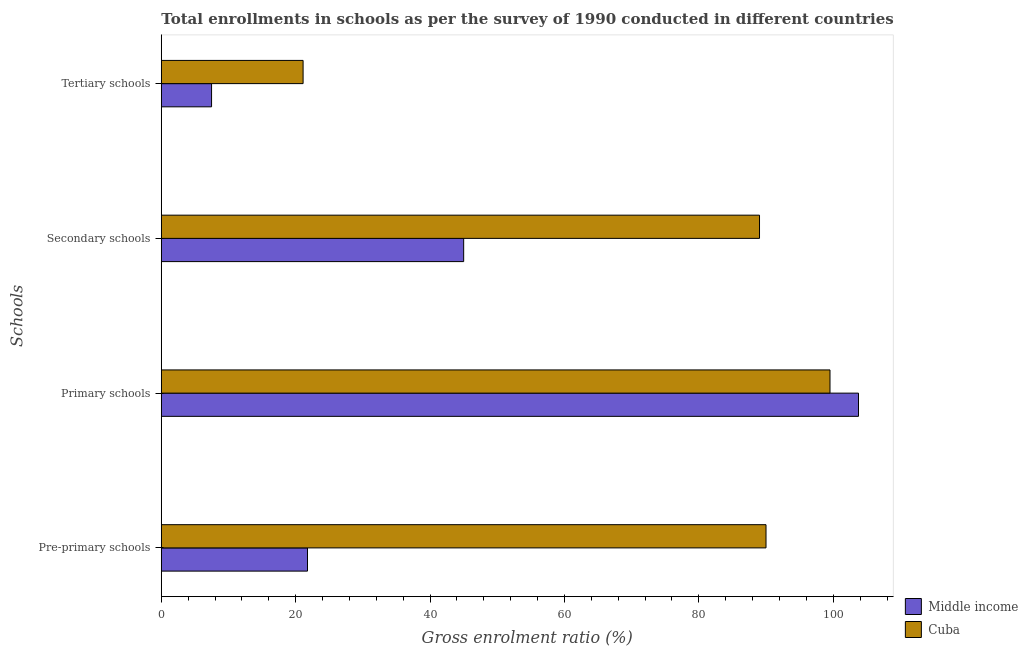How many different coloured bars are there?
Provide a succinct answer. 2. How many groups of bars are there?
Ensure brevity in your answer.  4. Are the number of bars per tick equal to the number of legend labels?
Your answer should be compact. Yes. What is the label of the 4th group of bars from the top?
Provide a short and direct response. Pre-primary schools. What is the gross enrolment ratio in pre-primary schools in Middle income?
Offer a very short reply. 21.76. Across all countries, what is the maximum gross enrolment ratio in primary schools?
Your answer should be compact. 103.76. Across all countries, what is the minimum gross enrolment ratio in primary schools?
Ensure brevity in your answer.  99.52. In which country was the gross enrolment ratio in tertiary schools maximum?
Your answer should be very brief. Cuba. What is the total gross enrolment ratio in tertiary schools in the graph?
Your answer should be compact. 28.58. What is the difference between the gross enrolment ratio in primary schools in Middle income and that in Cuba?
Offer a very short reply. 4.24. What is the difference between the gross enrolment ratio in primary schools in Middle income and the gross enrolment ratio in secondary schools in Cuba?
Ensure brevity in your answer.  14.73. What is the average gross enrolment ratio in pre-primary schools per country?
Offer a terse response. 55.88. What is the difference between the gross enrolment ratio in primary schools and gross enrolment ratio in secondary schools in Middle income?
Offer a very short reply. 58.76. What is the ratio of the gross enrolment ratio in primary schools in Cuba to that in Middle income?
Keep it short and to the point. 0.96. What is the difference between the highest and the second highest gross enrolment ratio in secondary schools?
Your answer should be compact. 44.03. What is the difference between the highest and the lowest gross enrolment ratio in tertiary schools?
Keep it short and to the point. 13.62. In how many countries, is the gross enrolment ratio in tertiary schools greater than the average gross enrolment ratio in tertiary schools taken over all countries?
Offer a terse response. 1. Is the sum of the gross enrolment ratio in primary schools in Middle income and Cuba greater than the maximum gross enrolment ratio in tertiary schools across all countries?
Keep it short and to the point. Yes. Is it the case that in every country, the sum of the gross enrolment ratio in tertiary schools and gross enrolment ratio in secondary schools is greater than the sum of gross enrolment ratio in pre-primary schools and gross enrolment ratio in primary schools?
Make the answer very short. No. What does the 1st bar from the top in Primary schools represents?
Offer a very short reply. Cuba. What does the 2nd bar from the bottom in Pre-primary schools represents?
Your response must be concise. Cuba. How many countries are there in the graph?
Your answer should be compact. 2. What is the difference between two consecutive major ticks on the X-axis?
Provide a succinct answer. 20. Are the values on the major ticks of X-axis written in scientific E-notation?
Keep it short and to the point. No. Does the graph contain any zero values?
Give a very brief answer. No. Where does the legend appear in the graph?
Make the answer very short. Bottom right. What is the title of the graph?
Provide a short and direct response. Total enrollments in schools as per the survey of 1990 conducted in different countries. What is the label or title of the X-axis?
Offer a terse response. Gross enrolment ratio (%). What is the label or title of the Y-axis?
Your answer should be compact. Schools. What is the Gross enrolment ratio (%) in Middle income in Pre-primary schools?
Give a very brief answer. 21.76. What is the Gross enrolment ratio (%) in Cuba in Pre-primary schools?
Offer a terse response. 89.99. What is the Gross enrolment ratio (%) of Middle income in Primary schools?
Provide a short and direct response. 103.76. What is the Gross enrolment ratio (%) in Cuba in Primary schools?
Offer a terse response. 99.52. What is the Gross enrolment ratio (%) of Middle income in Secondary schools?
Offer a terse response. 45. What is the Gross enrolment ratio (%) of Cuba in Secondary schools?
Offer a terse response. 89.03. What is the Gross enrolment ratio (%) in Middle income in Tertiary schools?
Ensure brevity in your answer.  7.48. What is the Gross enrolment ratio (%) of Cuba in Tertiary schools?
Make the answer very short. 21.1. Across all Schools, what is the maximum Gross enrolment ratio (%) in Middle income?
Keep it short and to the point. 103.76. Across all Schools, what is the maximum Gross enrolment ratio (%) in Cuba?
Provide a short and direct response. 99.52. Across all Schools, what is the minimum Gross enrolment ratio (%) in Middle income?
Offer a terse response. 7.48. Across all Schools, what is the minimum Gross enrolment ratio (%) in Cuba?
Your answer should be very brief. 21.1. What is the total Gross enrolment ratio (%) of Middle income in the graph?
Offer a very short reply. 177.99. What is the total Gross enrolment ratio (%) of Cuba in the graph?
Ensure brevity in your answer.  299.64. What is the difference between the Gross enrolment ratio (%) in Middle income in Pre-primary schools and that in Primary schools?
Make the answer very short. -82. What is the difference between the Gross enrolment ratio (%) in Cuba in Pre-primary schools and that in Primary schools?
Your answer should be very brief. -9.52. What is the difference between the Gross enrolment ratio (%) of Middle income in Pre-primary schools and that in Secondary schools?
Give a very brief answer. -23.24. What is the difference between the Gross enrolment ratio (%) of Cuba in Pre-primary schools and that in Secondary schools?
Your answer should be very brief. 0.97. What is the difference between the Gross enrolment ratio (%) in Middle income in Pre-primary schools and that in Tertiary schools?
Your answer should be very brief. 14.28. What is the difference between the Gross enrolment ratio (%) of Cuba in Pre-primary schools and that in Tertiary schools?
Give a very brief answer. 68.89. What is the difference between the Gross enrolment ratio (%) of Middle income in Primary schools and that in Secondary schools?
Offer a very short reply. 58.76. What is the difference between the Gross enrolment ratio (%) in Cuba in Primary schools and that in Secondary schools?
Offer a very short reply. 10.49. What is the difference between the Gross enrolment ratio (%) of Middle income in Primary schools and that in Tertiary schools?
Your answer should be very brief. 96.28. What is the difference between the Gross enrolment ratio (%) in Cuba in Primary schools and that in Tertiary schools?
Your response must be concise. 78.42. What is the difference between the Gross enrolment ratio (%) in Middle income in Secondary schools and that in Tertiary schools?
Keep it short and to the point. 37.52. What is the difference between the Gross enrolment ratio (%) in Cuba in Secondary schools and that in Tertiary schools?
Make the answer very short. 67.93. What is the difference between the Gross enrolment ratio (%) in Middle income in Pre-primary schools and the Gross enrolment ratio (%) in Cuba in Primary schools?
Offer a terse response. -77.76. What is the difference between the Gross enrolment ratio (%) in Middle income in Pre-primary schools and the Gross enrolment ratio (%) in Cuba in Secondary schools?
Offer a very short reply. -67.27. What is the difference between the Gross enrolment ratio (%) in Middle income in Pre-primary schools and the Gross enrolment ratio (%) in Cuba in Tertiary schools?
Provide a succinct answer. 0.66. What is the difference between the Gross enrolment ratio (%) of Middle income in Primary schools and the Gross enrolment ratio (%) of Cuba in Secondary schools?
Provide a succinct answer. 14.73. What is the difference between the Gross enrolment ratio (%) in Middle income in Primary schools and the Gross enrolment ratio (%) in Cuba in Tertiary schools?
Provide a succinct answer. 82.66. What is the difference between the Gross enrolment ratio (%) of Middle income in Secondary schools and the Gross enrolment ratio (%) of Cuba in Tertiary schools?
Offer a very short reply. 23.9. What is the average Gross enrolment ratio (%) of Middle income per Schools?
Provide a succinct answer. 44.5. What is the average Gross enrolment ratio (%) in Cuba per Schools?
Ensure brevity in your answer.  74.91. What is the difference between the Gross enrolment ratio (%) of Middle income and Gross enrolment ratio (%) of Cuba in Pre-primary schools?
Your response must be concise. -68.24. What is the difference between the Gross enrolment ratio (%) in Middle income and Gross enrolment ratio (%) in Cuba in Primary schools?
Your response must be concise. 4.24. What is the difference between the Gross enrolment ratio (%) of Middle income and Gross enrolment ratio (%) of Cuba in Secondary schools?
Offer a terse response. -44.03. What is the difference between the Gross enrolment ratio (%) in Middle income and Gross enrolment ratio (%) in Cuba in Tertiary schools?
Give a very brief answer. -13.62. What is the ratio of the Gross enrolment ratio (%) of Middle income in Pre-primary schools to that in Primary schools?
Your answer should be compact. 0.21. What is the ratio of the Gross enrolment ratio (%) in Cuba in Pre-primary schools to that in Primary schools?
Your answer should be very brief. 0.9. What is the ratio of the Gross enrolment ratio (%) in Middle income in Pre-primary schools to that in Secondary schools?
Provide a succinct answer. 0.48. What is the ratio of the Gross enrolment ratio (%) of Cuba in Pre-primary schools to that in Secondary schools?
Provide a short and direct response. 1.01. What is the ratio of the Gross enrolment ratio (%) of Middle income in Pre-primary schools to that in Tertiary schools?
Provide a short and direct response. 2.91. What is the ratio of the Gross enrolment ratio (%) in Cuba in Pre-primary schools to that in Tertiary schools?
Keep it short and to the point. 4.27. What is the ratio of the Gross enrolment ratio (%) in Middle income in Primary schools to that in Secondary schools?
Your answer should be compact. 2.31. What is the ratio of the Gross enrolment ratio (%) in Cuba in Primary schools to that in Secondary schools?
Your response must be concise. 1.12. What is the ratio of the Gross enrolment ratio (%) of Middle income in Primary schools to that in Tertiary schools?
Make the answer very short. 13.87. What is the ratio of the Gross enrolment ratio (%) of Cuba in Primary schools to that in Tertiary schools?
Your answer should be very brief. 4.72. What is the ratio of the Gross enrolment ratio (%) in Middle income in Secondary schools to that in Tertiary schools?
Offer a terse response. 6.02. What is the ratio of the Gross enrolment ratio (%) of Cuba in Secondary schools to that in Tertiary schools?
Provide a succinct answer. 4.22. What is the difference between the highest and the second highest Gross enrolment ratio (%) of Middle income?
Offer a terse response. 58.76. What is the difference between the highest and the second highest Gross enrolment ratio (%) of Cuba?
Provide a short and direct response. 9.52. What is the difference between the highest and the lowest Gross enrolment ratio (%) of Middle income?
Make the answer very short. 96.28. What is the difference between the highest and the lowest Gross enrolment ratio (%) in Cuba?
Offer a very short reply. 78.42. 